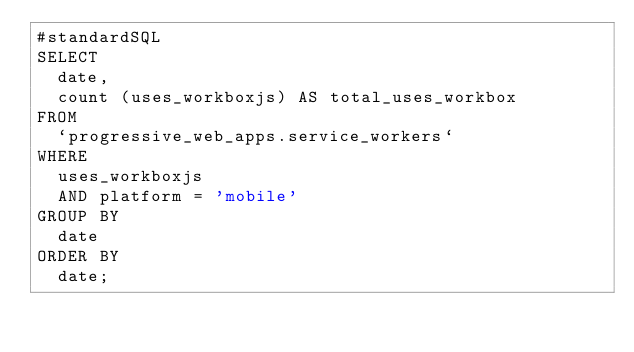Convert code to text. <code><loc_0><loc_0><loc_500><loc_500><_SQL_>#standardSQL
SELECT
  date,
  count (uses_workboxjs) AS total_uses_workbox
FROM
  `progressive_web_apps.service_workers`
WHERE
  uses_workboxjs
  AND platform = 'mobile'
GROUP BY
  date
ORDER BY
  date;</code> 